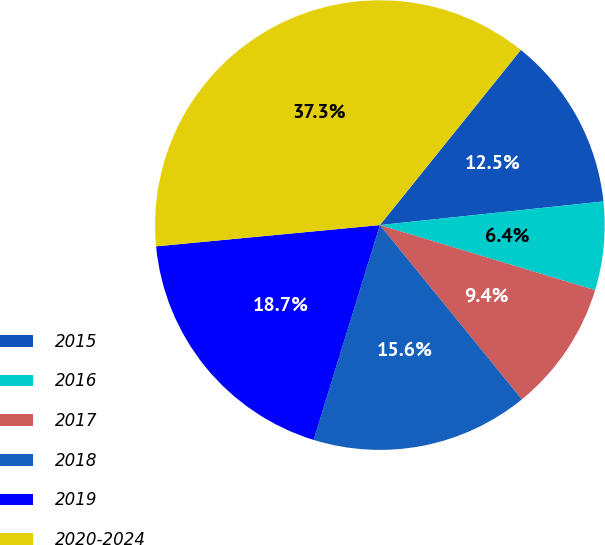Convert chart. <chart><loc_0><loc_0><loc_500><loc_500><pie_chart><fcel>2015<fcel>2016<fcel>2017<fcel>2018<fcel>2019<fcel>2020-2024<nl><fcel>12.54%<fcel>6.35%<fcel>9.45%<fcel>15.64%<fcel>18.73%<fcel>37.29%<nl></chart> 